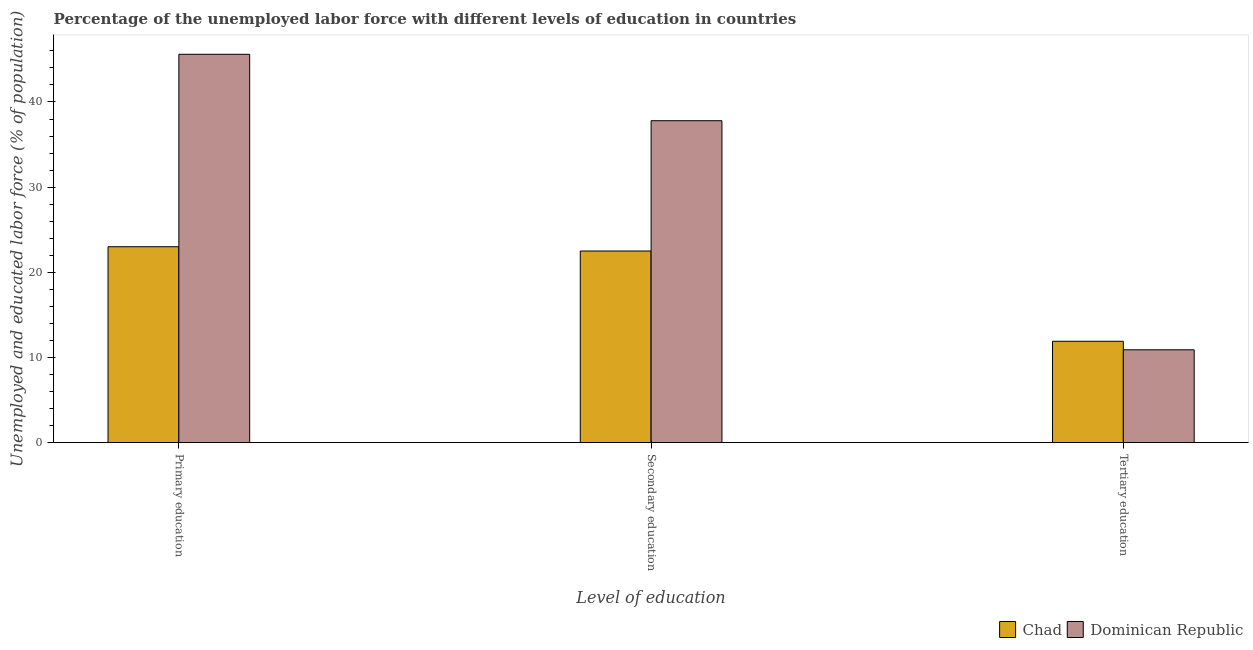Are the number of bars on each tick of the X-axis equal?
Provide a short and direct response. Yes. How many bars are there on the 2nd tick from the left?
Ensure brevity in your answer.  2. How many bars are there on the 3rd tick from the right?
Offer a terse response. 2. What is the label of the 3rd group of bars from the left?
Offer a terse response. Tertiary education. What is the percentage of labor force who received tertiary education in Dominican Republic?
Offer a very short reply. 10.9. Across all countries, what is the maximum percentage of labor force who received tertiary education?
Make the answer very short. 11.9. Across all countries, what is the minimum percentage of labor force who received tertiary education?
Your answer should be very brief. 10.9. In which country was the percentage of labor force who received secondary education maximum?
Provide a succinct answer. Dominican Republic. In which country was the percentage of labor force who received tertiary education minimum?
Ensure brevity in your answer.  Dominican Republic. What is the total percentage of labor force who received secondary education in the graph?
Your answer should be very brief. 60.3. What is the difference between the percentage of labor force who received secondary education in Chad and that in Dominican Republic?
Provide a short and direct response. -15.3. What is the difference between the percentage of labor force who received tertiary education in Dominican Republic and the percentage of labor force who received primary education in Chad?
Your answer should be compact. -12.1. What is the average percentage of labor force who received primary education per country?
Your answer should be compact. 34.3. What is the ratio of the percentage of labor force who received tertiary education in Chad to that in Dominican Republic?
Ensure brevity in your answer.  1.09. Is the percentage of labor force who received tertiary education in Dominican Republic less than that in Chad?
Offer a terse response. Yes. Is the difference between the percentage of labor force who received secondary education in Dominican Republic and Chad greater than the difference between the percentage of labor force who received primary education in Dominican Republic and Chad?
Offer a very short reply. No. What is the difference between the highest and the second highest percentage of labor force who received primary education?
Your answer should be compact. 22.6. What is the difference between the highest and the lowest percentage of labor force who received tertiary education?
Give a very brief answer. 1. In how many countries, is the percentage of labor force who received tertiary education greater than the average percentage of labor force who received tertiary education taken over all countries?
Provide a succinct answer. 1. Is the sum of the percentage of labor force who received primary education in Chad and Dominican Republic greater than the maximum percentage of labor force who received secondary education across all countries?
Your response must be concise. Yes. What does the 2nd bar from the left in Secondary education represents?
Offer a terse response. Dominican Republic. What does the 1st bar from the right in Primary education represents?
Provide a short and direct response. Dominican Republic. Is it the case that in every country, the sum of the percentage of labor force who received primary education and percentage of labor force who received secondary education is greater than the percentage of labor force who received tertiary education?
Make the answer very short. Yes. Are all the bars in the graph horizontal?
Offer a very short reply. No. What is the difference between two consecutive major ticks on the Y-axis?
Provide a succinct answer. 10. Does the graph contain any zero values?
Keep it short and to the point. No. Does the graph contain grids?
Provide a succinct answer. No. How many legend labels are there?
Ensure brevity in your answer.  2. What is the title of the graph?
Make the answer very short. Percentage of the unemployed labor force with different levels of education in countries. What is the label or title of the X-axis?
Provide a short and direct response. Level of education. What is the label or title of the Y-axis?
Your answer should be very brief. Unemployed and educated labor force (% of population). What is the Unemployed and educated labor force (% of population) of Chad in Primary education?
Your answer should be compact. 23. What is the Unemployed and educated labor force (% of population) of Dominican Republic in Primary education?
Provide a short and direct response. 45.6. What is the Unemployed and educated labor force (% of population) in Chad in Secondary education?
Your response must be concise. 22.5. What is the Unemployed and educated labor force (% of population) in Dominican Republic in Secondary education?
Provide a succinct answer. 37.8. What is the Unemployed and educated labor force (% of population) in Chad in Tertiary education?
Ensure brevity in your answer.  11.9. What is the Unemployed and educated labor force (% of population) of Dominican Republic in Tertiary education?
Give a very brief answer. 10.9. Across all Level of education, what is the maximum Unemployed and educated labor force (% of population) of Chad?
Ensure brevity in your answer.  23. Across all Level of education, what is the maximum Unemployed and educated labor force (% of population) in Dominican Republic?
Offer a very short reply. 45.6. Across all Level of education, what is the minimum Unemployed and educated labor force (% of population) in Chad?
Give a very brief answer. 11.9. Across all Level of education, what is the minimum Unemployed and educated labor force (% of population) in Dominican Republic?
Provide a succinct answer. 10.9. What is the total Unemployed and educated labor force (% of population) in Chad in the graph?
Ensure brevity in your answer.  57.4. What is the total Unemployed and educated labor force (% of population) in Dominican Republic in the graph?
Offer a terse response. 94.3. What is the difference between the Unemployed and educated labor force (% of population) in Chad in Primary education and that in Secondary education?
Provide a short and direct response. 0.5. What is the difference between the Unemployed and educated labor force (% of population) of Chad in Primary education and that in Tertiary education?
Provide a short and direct response. 11.1. What is the difference between the Unemployed and educated labor force (% of population) in Dominican Republic in Primary education and that in Tertiary education?
Offer a terse response. 34.7. What is the difference between the Unemployed and educated labor force (% of population) of Dominican Republic in Secondary education and that in Tertiary education?
Make the answer very short. 26.9. What is the difference between the Unemployed and educated labor force (% of population) of Chad in Primary education and the Unemployed and educated labor force (% of population) of Dominican Republic in Secondary education?
Your answer should be very brief. -14.8. What is the difference between the Unemployed and educated labor force (% of population) in Chad in Primary education and the Unemployed and educated labor force (% of population) in Dominican Republic in Tertiary education?
Provide a succinct answer. 12.1. What is the difference between the Unemployed and educated labor force (% of population) of Chad in Secondary education and the Unemployed and educated labor force (% of population) of Dominican Republic in Tertiary education?
Ensure brevity in your answer.  11.6. What is the average Unemployed and educated labor force (% of population) of Chad per Level of education?
Offer a very short reply. 19.13. What is the average Unemployed and educated labor force (% of population) of Dominican Republic per Level of education?
Make the answer very short. 31.43. What is the difference between the Unemployed and educated labor force (% of population) of Chad and Unemployed and educated labor force (% of population) of Dominican Republic in Primary education?
Offer a very short reply. -22.6. What is the difference between the Unemployed and educated labor force (% of population) of Chad and Unemployed and educated labor force (% of population) of Dominican Republic in Secondary education?
Ensure brevity in your answer.  -15.3. What is the ratio of the Unemployed and educated labor force (% of population) of Chad in Primary education to that in Secondary education?
Offer a terse response. 1.02. What is the ratio of the Unemployed and educated labor force (% of population) of Dominican Republic in Primary education to that in Secondary education?
Keep it short and to the point. 1.21. What is the ratio of the Unemployed and educated labor force (% of population) of Chad in Primary education to that in Tertiary education?
Provide a short and direct response. 1.93. What is the ratio of the Unemployed and educated labor force (% of population) in Dominican Republic in Primary education to that in Tertiary education?
Offer a very short reply. 4.18. What is the ratio of the Unemployed and educated labor force (% of population) in Chad in Secondary education to that in Tertiary education?
Offer a very short reply. 1.89. What is the ratio of the Unemployed and educated labor force (% of population) in Dominican Republic in Secondary education to that in Tertiary education?
Offer a very short reply. 3.47. What is the difference between the highest and the second highest Unemployed and educated labor force (% of population) of Dominican Republic?
Provide a succinct answer. 7.8. What is the difference between the highest and the lowest Unemployed and educated labor force (% of population) in Chad?
Make the answer very short. 11.1. What is the difference between the highest and the lowest Unemployed and educated labor force (% of population) of Dominican Republic?
Your answer should be very brief. 34.7. 